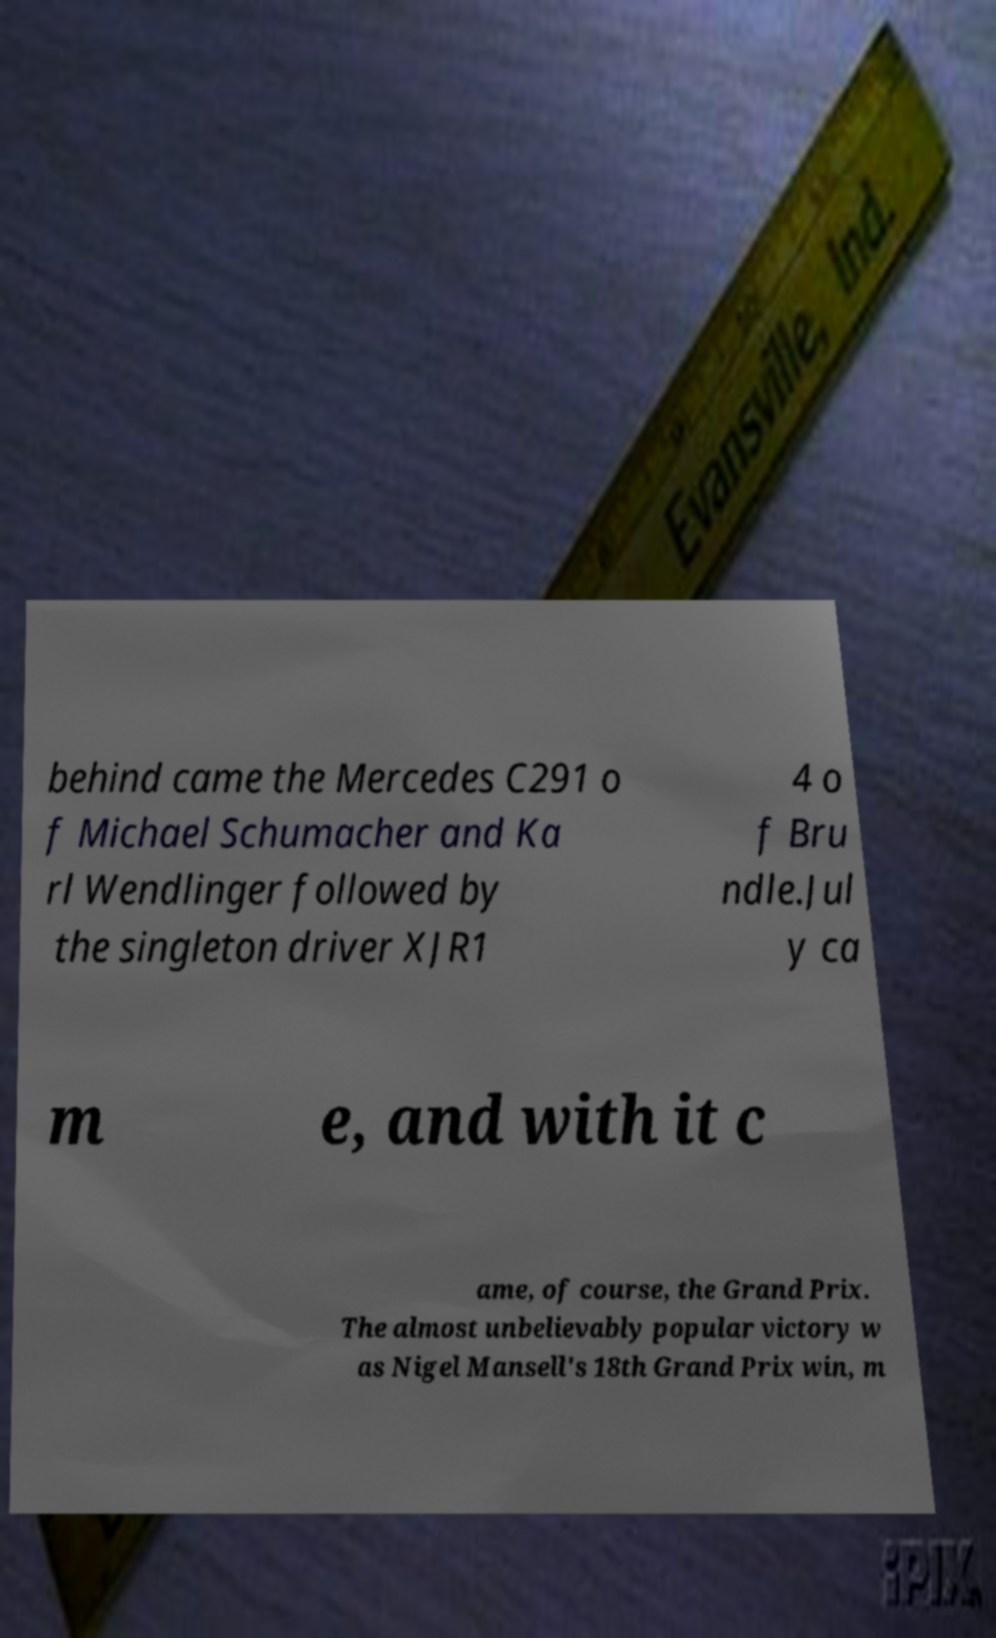Could you extract and type out the text from this image? behind came the Mercedes C291 o f Michael Schumacher and Ka rl Wendlinger followed by the singleton driver XJR1 4 o f Bru ndle.Jul y ca m e, and with it c ame, of course, the Grand Prix. The almost unbelievably popular victory w as Nigel Mansell's 18th Grand Prix win, m 